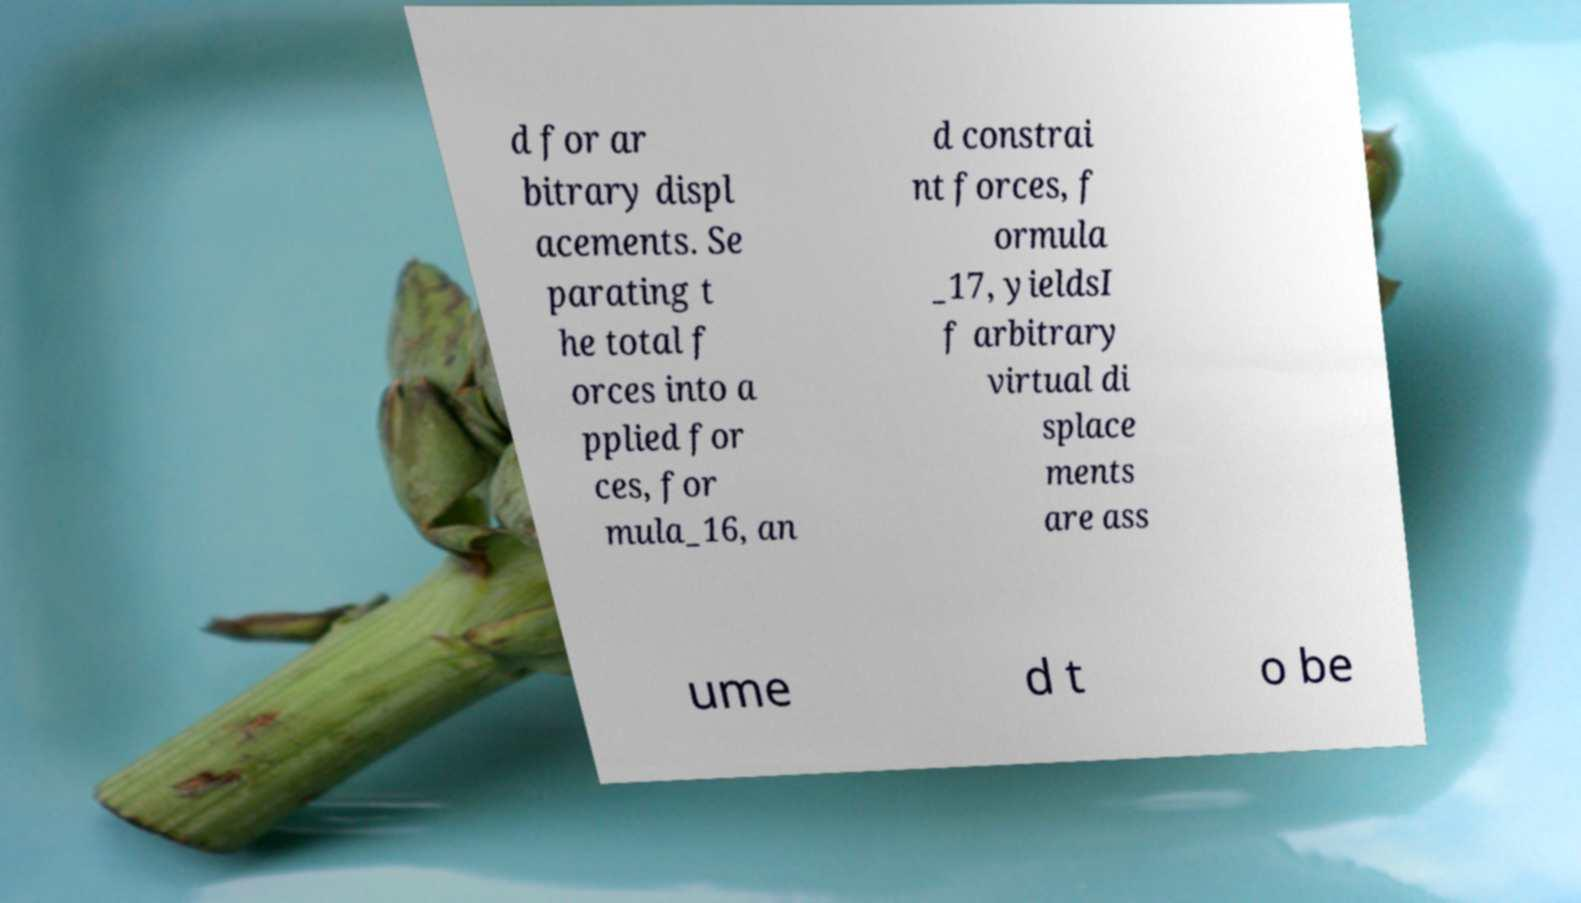Could you assist in decoding the text presented in this image and type it out clearly? d for ar bitrary displ acements. Se parating t he total f orces into a pplied for ces, for mula_16, an d constrai nt forces, f ormula _17, yieldsI f arbitrary virtual di splace ments are ass ume d t o be 